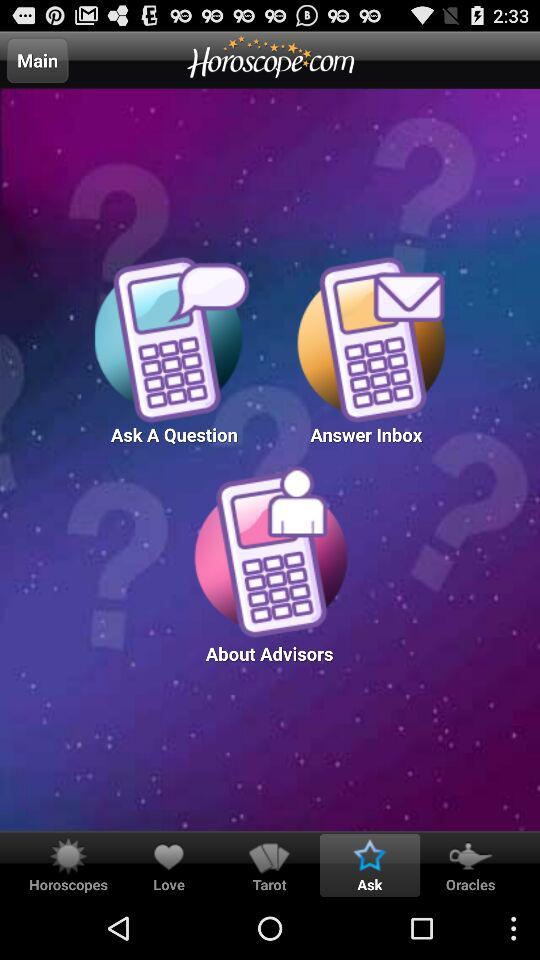Which tab has been selected? The selected tab is "Ask". 